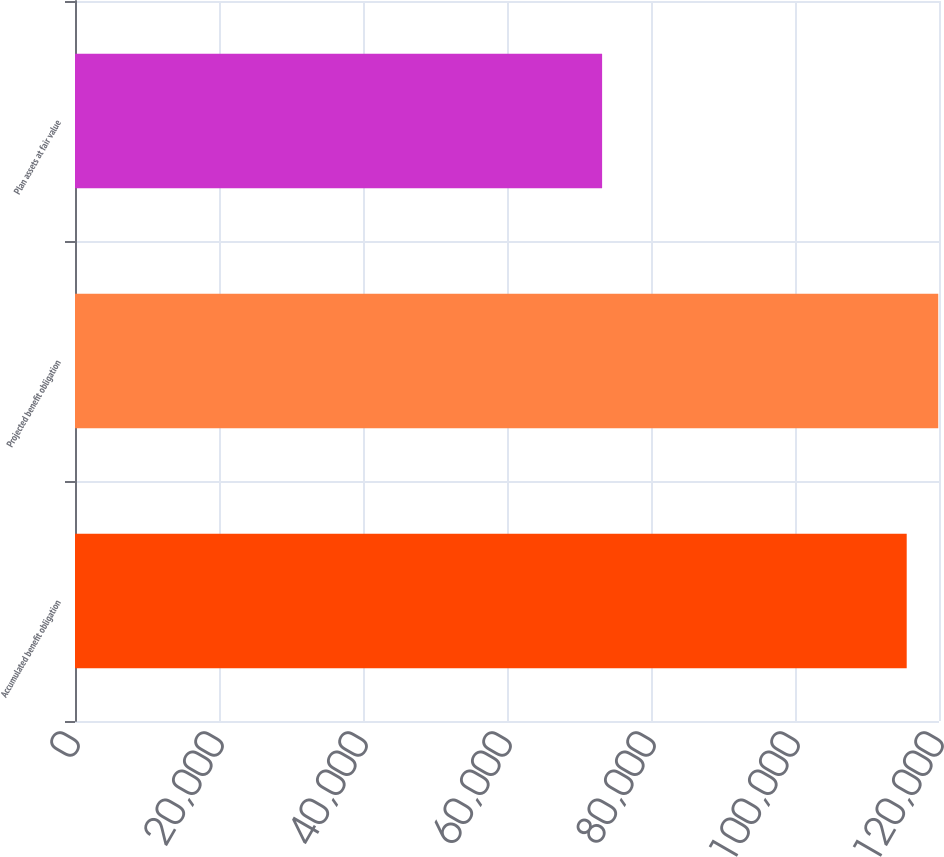Convert chart to OTSL. <chart><loc_0><loc_0><loc_500><loc_500><bar_chart><fcel>Accumulated benefit obligation<fcel>Projected benefit obligation<fcel>Plan assets at fair value<nl><fcel>115515<fcel>119893<fcel>73210<nl></chart> 